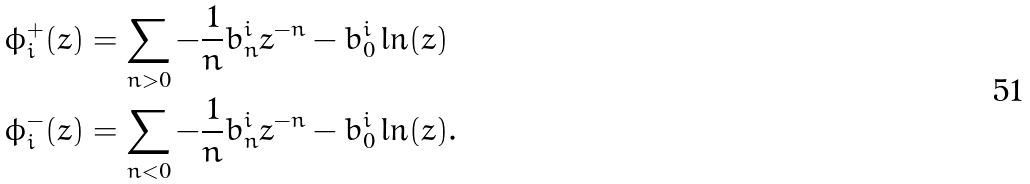<formula> <loc_0><loc_0><loc_500><loc_500>\phi _ { i } ^ { + } ( z ) & = \sum _ { n > 0 } - \frac { 1 } { n } b _ { n } ^ { i } z ^ { - n } - b _ { 0 } ^ { i } \ln ( z ) \\ \phi _ { i } ^ { - } ( z ) & = \sum _ { n < 0 } - \frac { 1 } { n } b _ { n } ^ { i } z ^ { - n } - b _ { 0 } ^ { i } \ln ( z ) .</formula> 